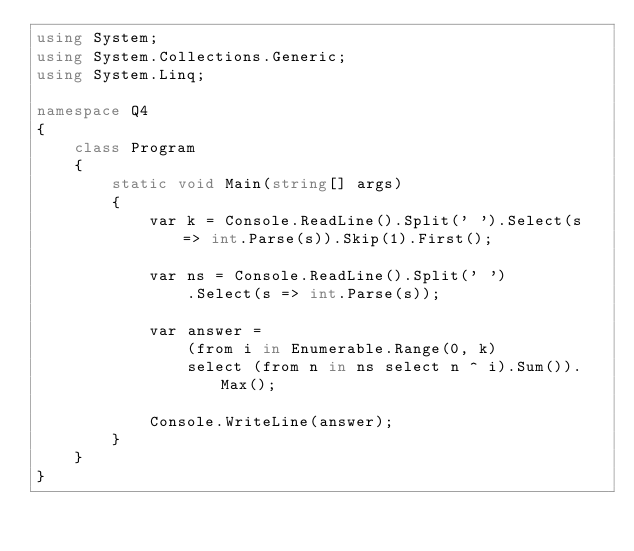Convert code to text. <code><loc_0><loc_0><loc_500><loc_500><_C#_>using System;
using System.Collections.Generic;
using System.Linq;

namespace Q4
{
    class Program
    {
        static void Main(string[] args)
        {
            var k = Console.ReadLine().Split(' ').Select(s => int.Parse(s)).Skip(1).First();

            var ns = Console.ReadLine().Split(' ')
                .Select(s => int.Parse(s));

            var answer =
                (from i in Enumerable.Range(0, k)
                select (from n in ns select n ^ i).Sum()).Max();

            Console.WriteLine(answer);
        }
    }
}
</code> 